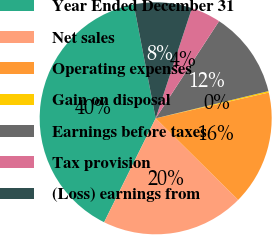<chart> <loc_0><loc_0><loc_500><loc_500><pie_chart><fcel>Year Ended December 31<fcel>Net sales<fcel>Operating expenses<fcel>Gain on disposal<fcel>Earnings before taxes<fcel>Tax provision<fcel>(Loss) earnings from<nl><fcel>39.64%<fcel>19.92%<fcel>15.98%<fcel>0.2%<fcel>12.03%<fcel>4.14%<fcel>8.09%<nl></chart> 